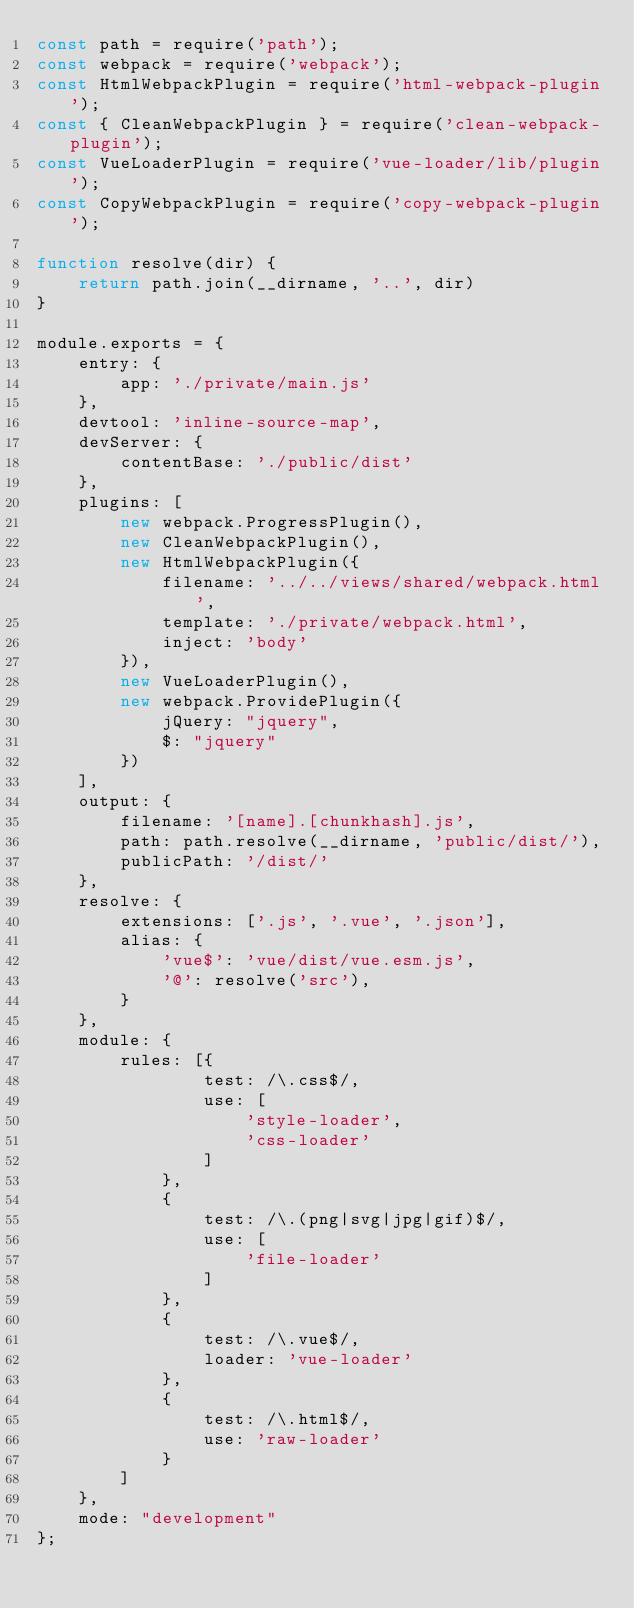Convert code to text. <code><loc_0><loc_0><loc_500><loc_500><_JavaScript_>const path = require('path');
const webpack = require('webpack');
const HtmlWebpackPlugin = require('html-webpack-plugin');
const { CleanWebpackPlugin } = require('clean-webpack-plugin');
const VueLoaderPlugin = require('vue-loader/lib/plugin');
const CopyWebpackPlugin = require('copy-webpack-plugin');

function resolve(dir) {
    return path.join(__dirname, '..', dir)
}

module.exports = {
    entry: {
        app: './private/main.js'
    },
    devtool: 'inline-source-map',
    devServer: {
        contentBase: './public/dist'
    },
    plugins: [
        new webpack.ProgressPlugin(),
        new CleanWebpackPlugin(),
        new HtmlWebpackPlugin({
            filename: '../../views/shared/webpack.html',
            template: './private/webpack.html',
            inject: 'body'
        }),
        new VueLoaderPlugin(),
        new webpack.ProvidePlugin({
            jQuery: "jquery",
            $: "jquery"
        })
    ],
    output: {
        filename: '[name].[chunkhash].js',
        path: path.resolve(__dirname, 'public/dist/'),
        publicPath: '/dist/'
    },
    resolve: {
        extensions: ['.js', '.vue', '.json'],
        alias: {
            'vue$': 'vue/dist/vue.esm.js',
            '@': resolve('src'),
        }
    },
    module: {
        rules: [{
                test: /\.css$/,
                use: [
                    'style-loader',
                    'css-loader'
                ]
            },
            {
                test: /\.(png|svg|jpg|gif)$/,
                use: [
                    'file-loader'
                ]
            },
            {
                test: /\.vue$/,
                loader: 'vue-loader'
            },
            {
                test: /\.html$/,
                use: 'raw-loader'
            }
        ]
    },
    mode: "development"
};</code> 